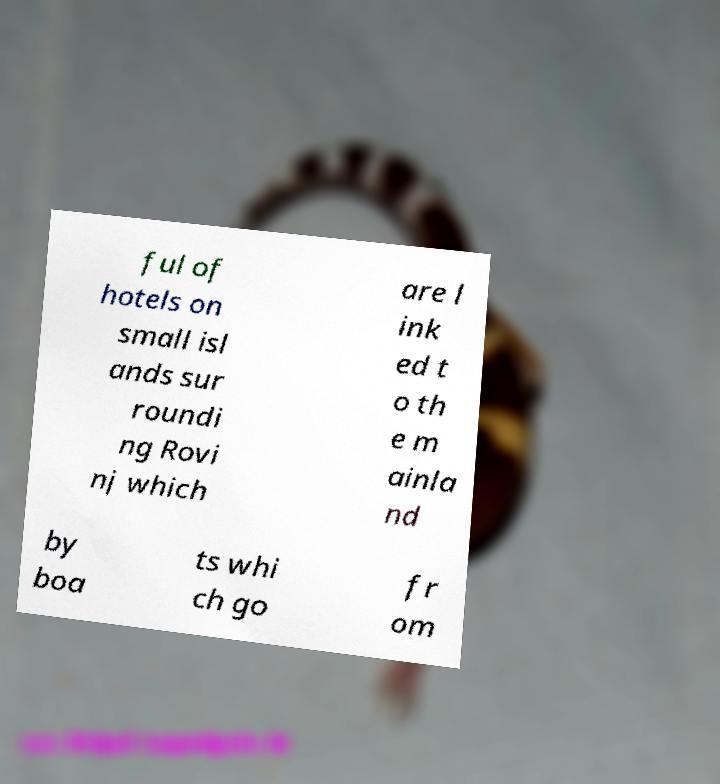Could you assist in decoding the text presented in this image and type it out clearly? ful of hotels on small isl ands sur roundi ng Rovi nj which are l ink ed t o th e m ainla nd by boa ts whi ch go fr om 